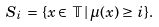Convert formula to latex. <formula><loc_0><loc_0><loc_500><loc_500>S _ { i } \, = \, \{ x \in \, \mathbb { T } \, | \, \mu ( x ) \geq \, i \} .</formula> 